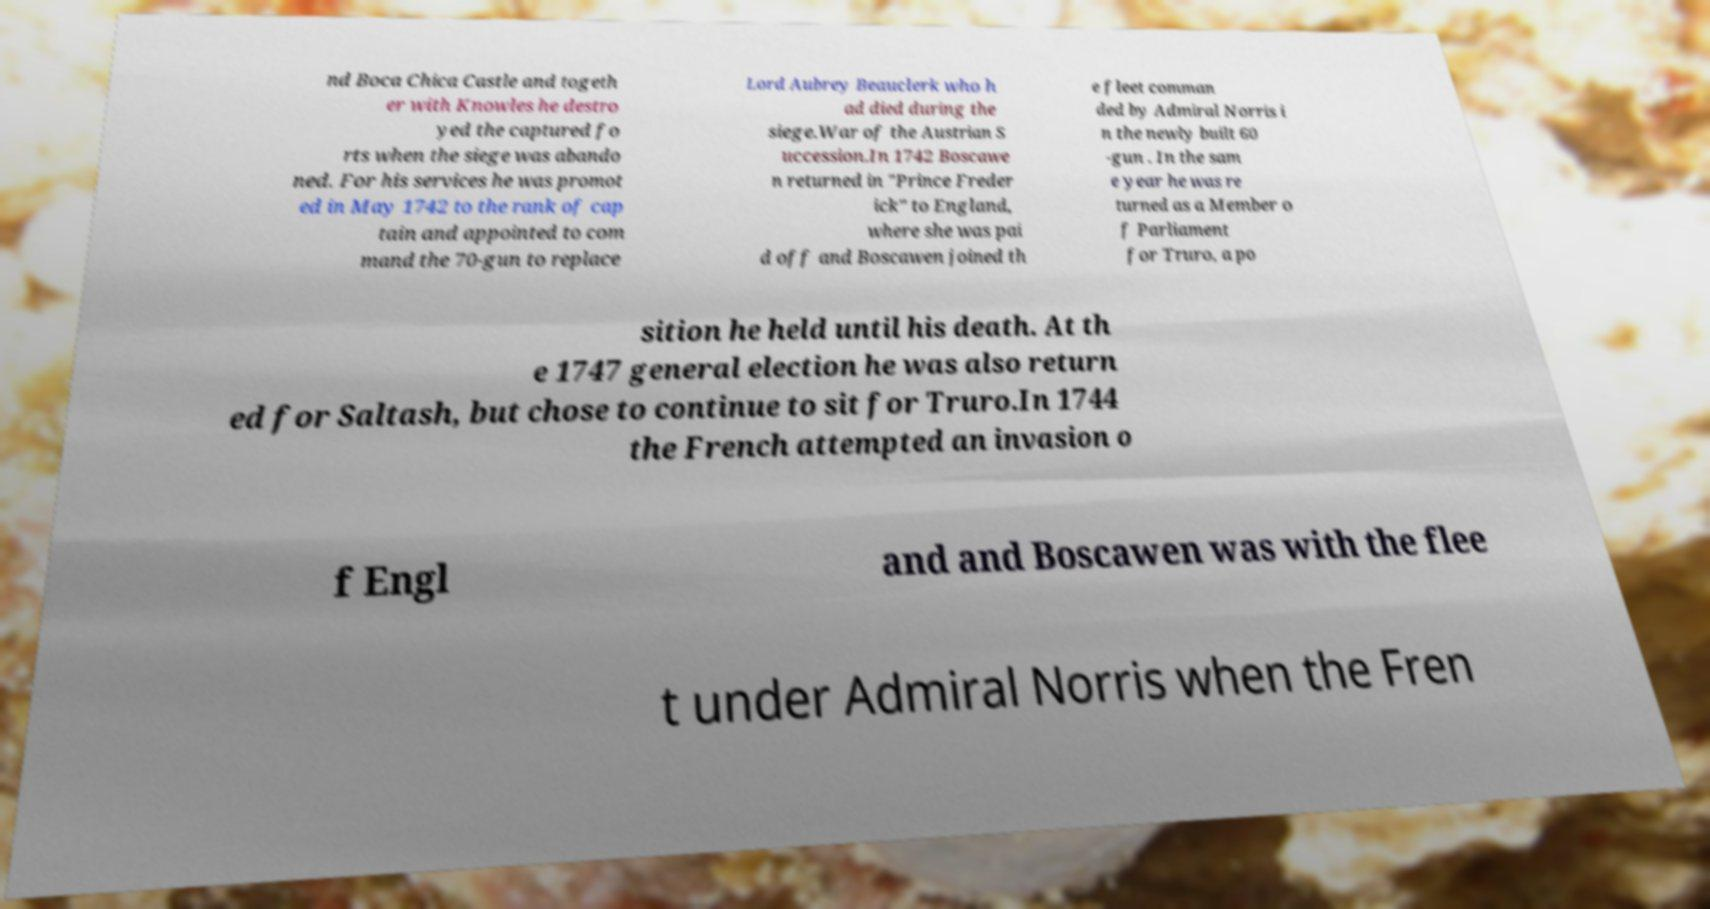There's text embedded in this image that I need extracted. Can you transcribe it verbatim? nd Boca Chica Castle and togeth er with Knowles he destro yed the captured fo rts when the siege was abando ned. For his services he was promot ed in May 1742 to the rank of cap tain and appointed to com mand the 70-gun to replace Lord Aubrey Beauclerk who h ad died during the siege.War of the Austrian S uccession.In 1742 Boscawe n returned in "Prince Freder ick" to England, where she was pai d off and Boscawen joined th e fleet comman ded by Admiral Norris i n the newly built 60 -gun . In the sam e year he was re turned as a Member o f Parliament for Truro, a po sition he held until his death. At th e 1747 general election he was also return ed for Saltash, but chose to continue to sit for Truro.In 1744 the French attempted an invasion o f Engl and and Boscawen was with the flee t under Admiral Norris when the Fren 